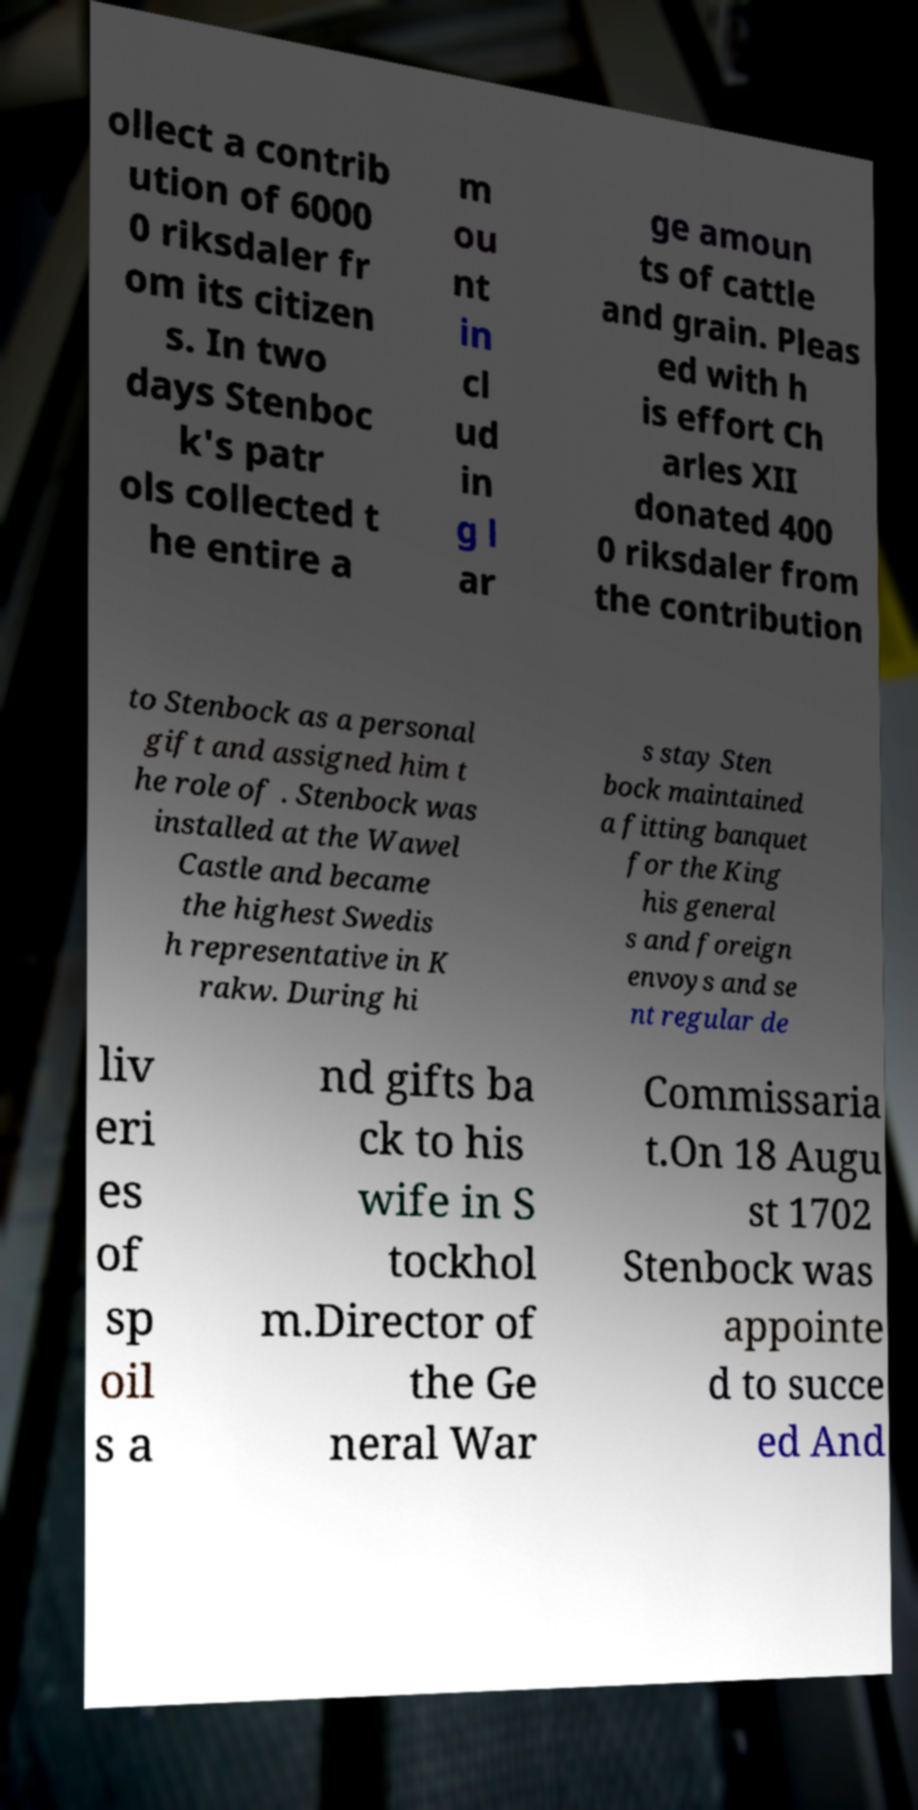Can you read and provide the text displayed in the image?This photo seems to have some interesting text. Can you extract and type it out for me? ollect a contrib ution of 6000 0 riksdaler fr om its citizen s. In two days Stenboc k's patr ols collected t he entire a m ou nt in cl ud in g l ar ge amoun ts of cattle and grain. Pleas ed with h is effort Ch arles XII donated 400 0 riksdaler from the contribution to Stenbock as a personal gift and assigned him t he role of . Stenbock was installed at the Wawel Castle and became the highest Swedis h representative in K rakw. During hi s stay Sten bock maintained a fitting banquet for the King his general s and foreign envoys and se nt regular de liv eri es of sp oil s a nd gifts ba ck to his wife in S tockhol m.Director of the Ge neral War Commissaria t.On 18 Augu st 1702 Stenbock was appointe d to succe ed And 